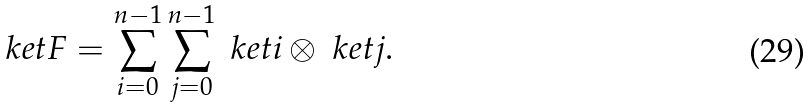Convert formula to latex. <formula><loc_0><loc_0><loc_500><loc_500>\ k e t { F } = \sum _ { i = 0 } ^ { n - 1 } \sum _ { j = 0 } ^ { n - 1 } \ k e t { i } \otimes \ k e t { j } .</formula> 